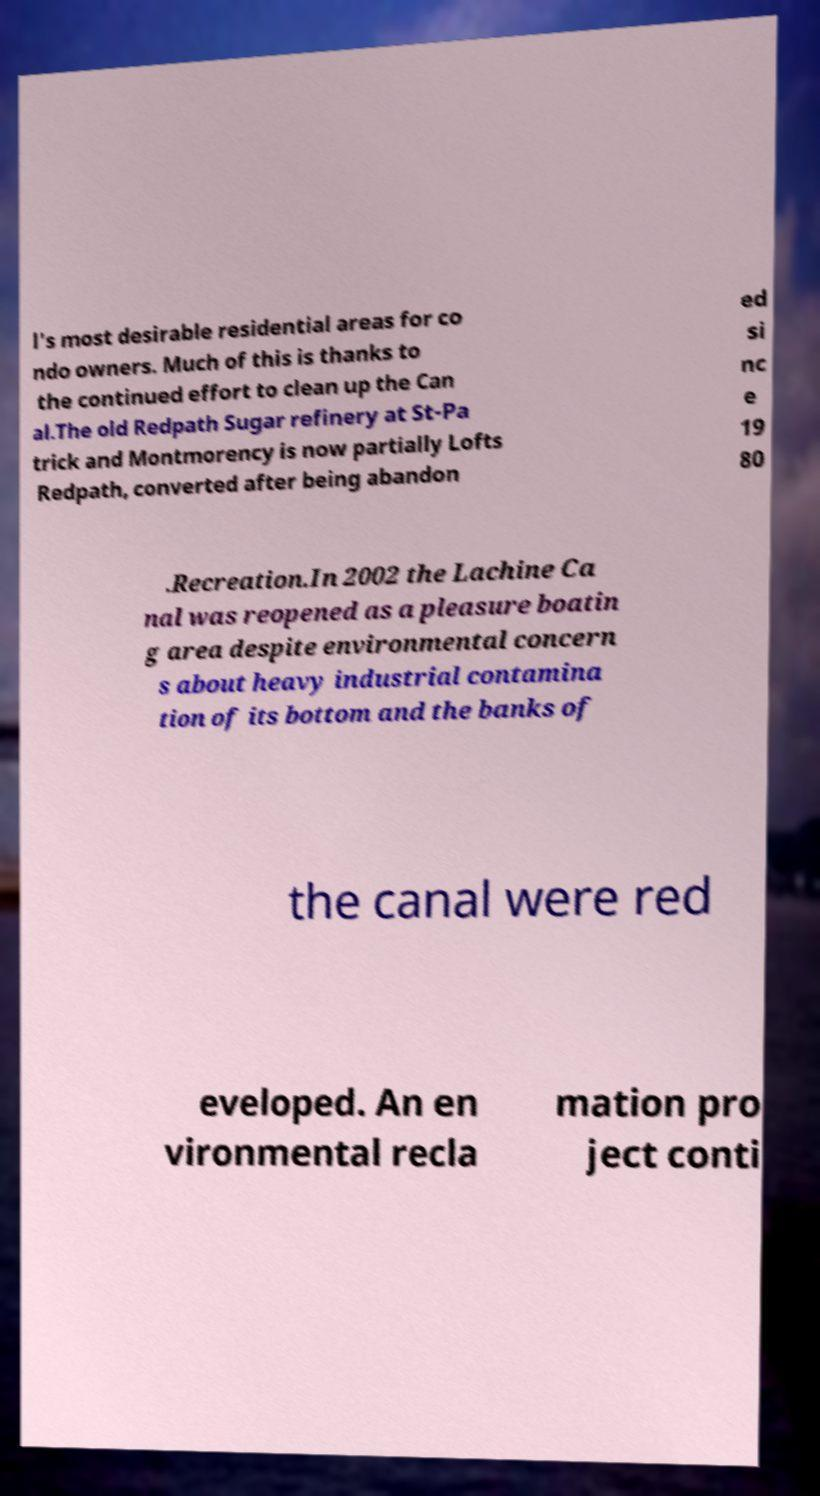Please read and relay the text visible in this image. What does it say? l's most desirable residential areas for co ndo owners. Much of this is thanks to the continued effort to clean up the Can al.The old Redpath Sugar refinery at St-Pa trick and Montmorency is now partially Lofts Redpath, converted after being abandon ed si nc e 19 80 .Recreation.In 2002 the Lachine Ca nal was reopened as a pleasure boatin g area despite environmental concern s about heavy industrial contamina tion of its bottom and the banks of the canal were red eveloped. An en vironmental recla mation pro ject conti 